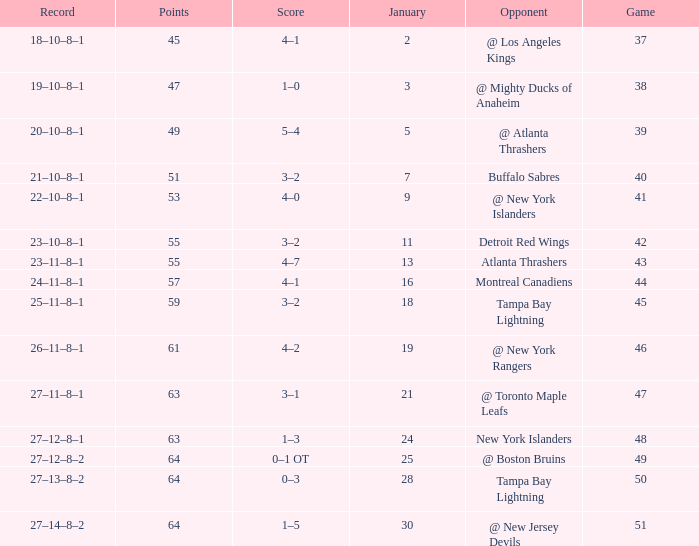Which Score has Points of 64, and a Game of 49? 0–1 OT. 